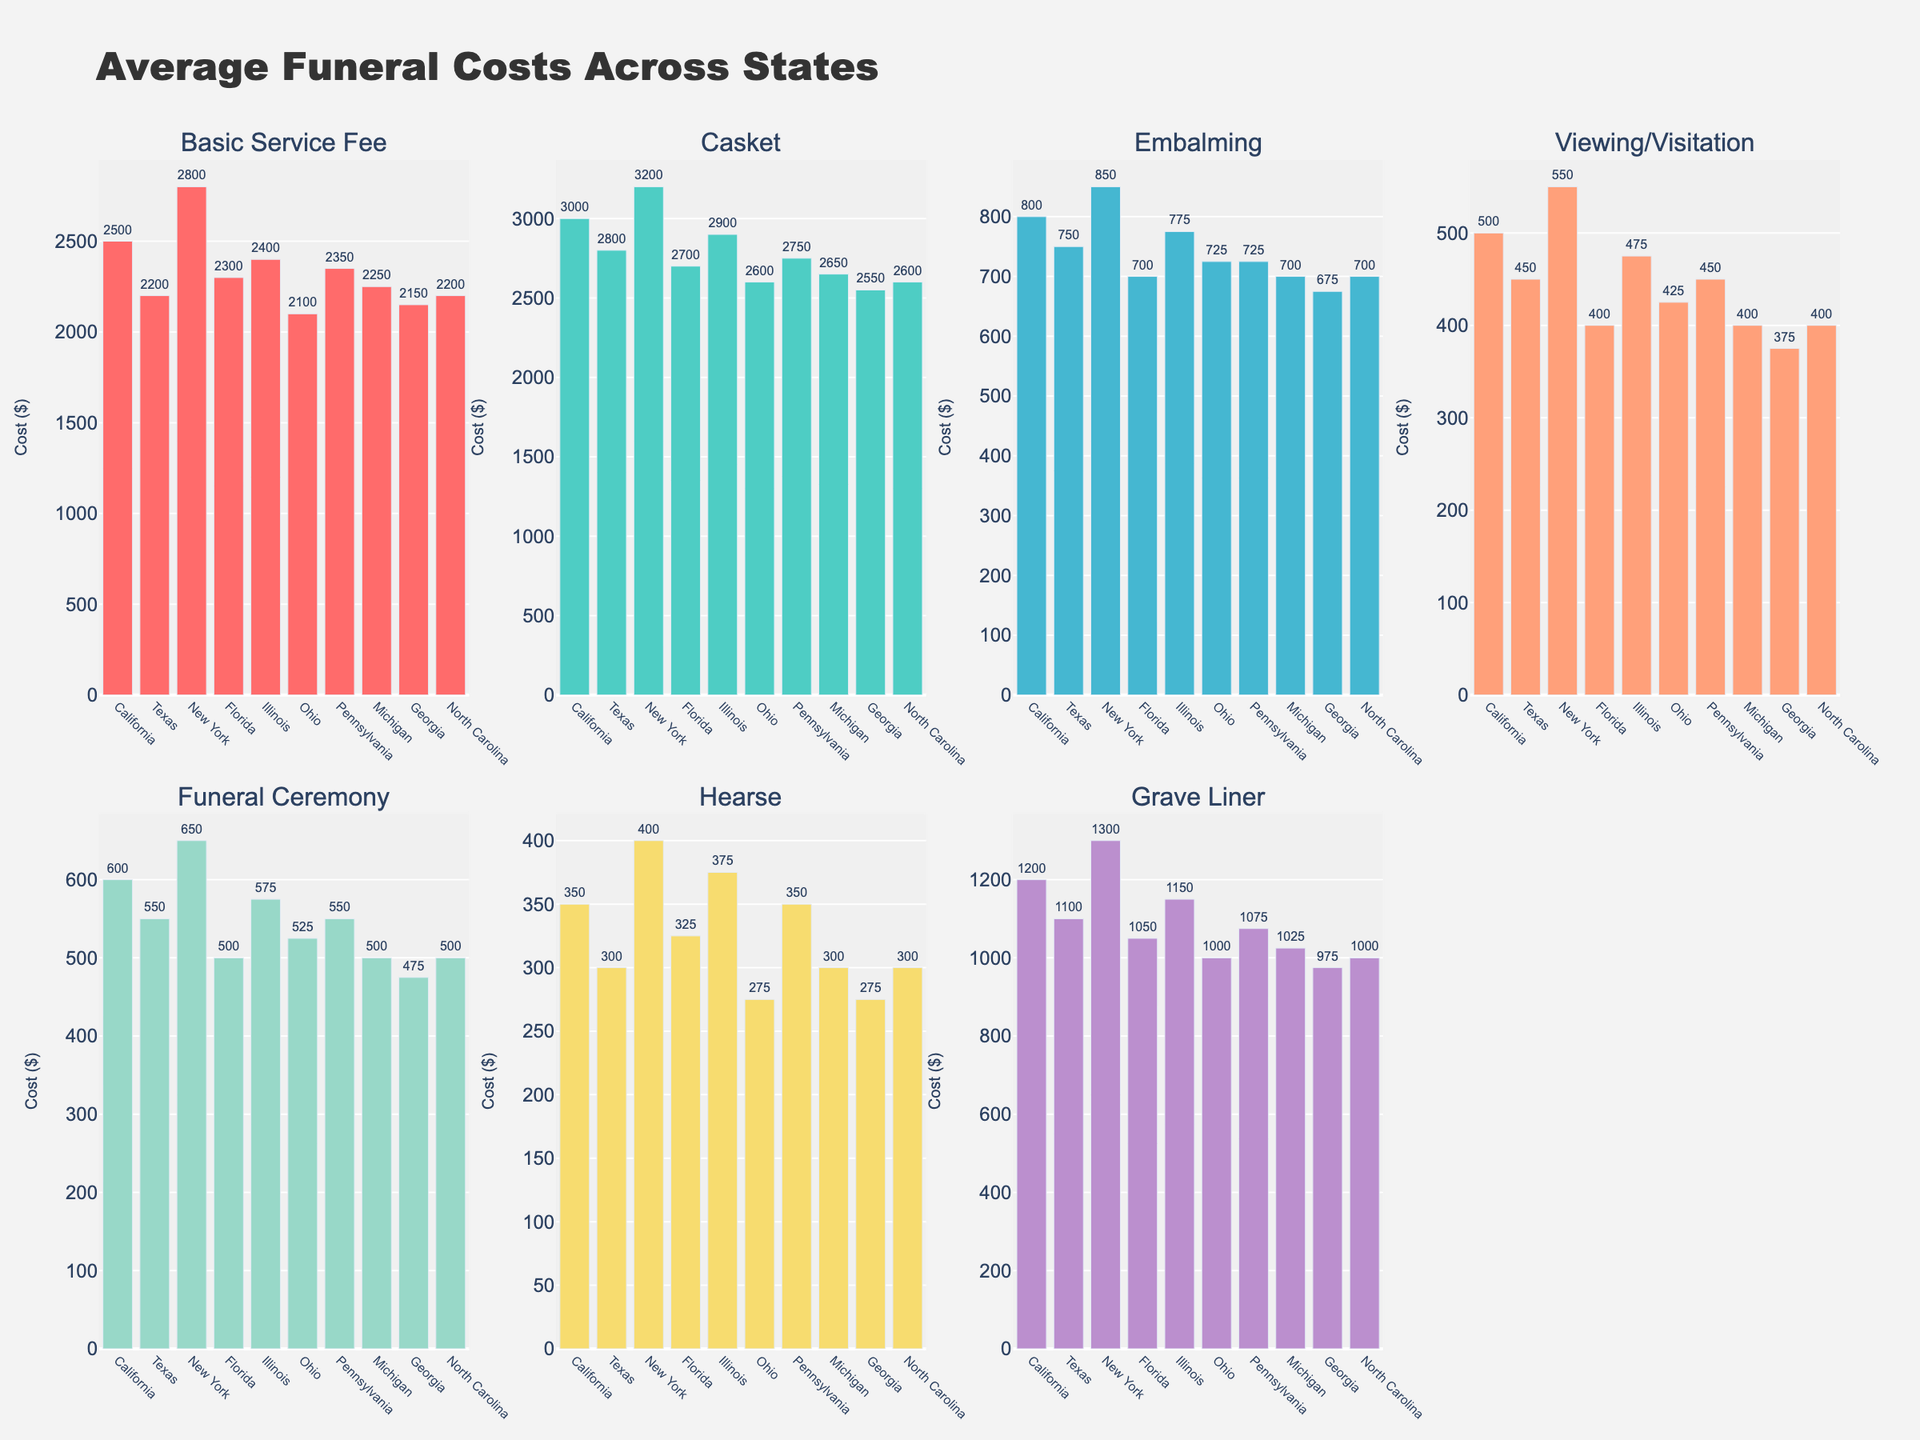Which state has the highest basic service fee? The basic service fee bar chart shows California with the highest value.
Answer: California Which state has the lowest cost for embalming? The embalming bar chart shows Florida with the lowest value.
Answer: Florida What is the average cost of a casket across all states? Add all casket costs and divide by the number of states: (3000 + 2800 + 3200 + 2700 + 2900 + 2600 + 2750 + 2650 + 2550 + 2600) / 10 = 2775.
Answer: $2775 Which funeral component is the most expensive in most states? The casket cost is the highest bar in nearly every subplot, indicating it is the most expensive component in most states.
Answer: Casket Compare the hearse costs between New York and Michigan. Which state is higher and by how much? In the hearse bar chart, New York is 400, and Michigan is 300; the difference is 400 - 300 = 100.
Answer: New York by $100 What is the total cost of all components in Illinois? Sum of all costs in Illinois: 2400 + 2900 + 775 + 475 + 575 + 375 + 1150 = 8650.
Answer: $8650 In how many states is the viewing/visitation cost below $500? States with viewing/visitation costs below $500 are Florida, Michigan, Georgia, and North Carolina. Total = 4.
Answer: 4 Which state has the highest cost for the funeral ceremony? The funeral ceremony bar chart shows New York with the highest value.
Answer: New York What is the difference in basic service fee between Ohio and California? Difference: 2500 (California) - 2100 (Ohio) = 400.
Answer: $400 Based on the plots, which service component has the least variation in cost across states? The hearse costs have the smallest range visually, indicating the least variation across states.
Answer: Hearse 